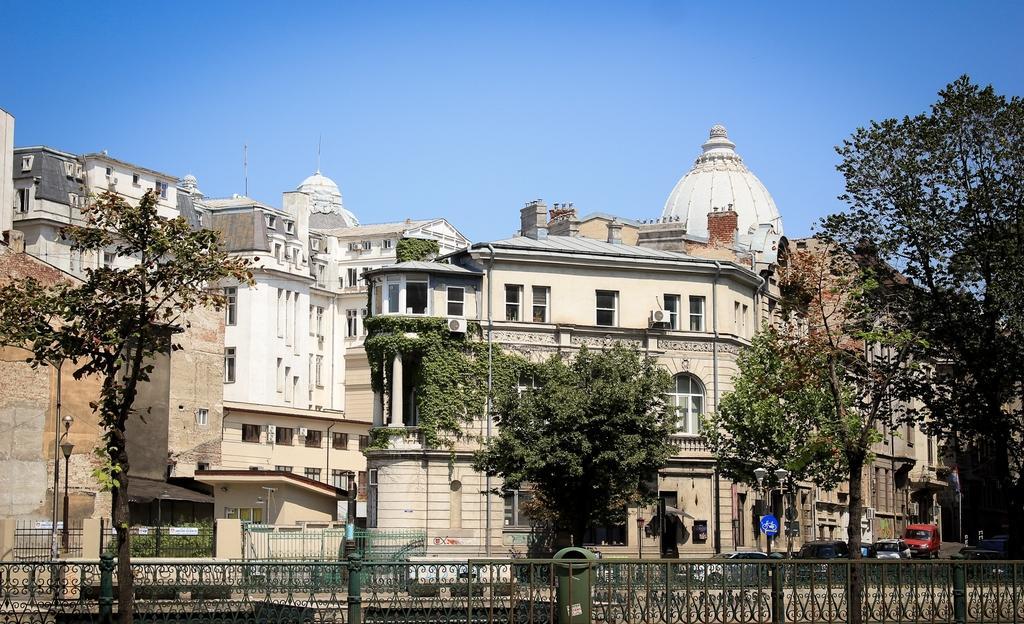Could you give a brief overview of what you see in this image? In the image there are buildings in the back with trees in front of it and vehicles going on the road and above its sky. 